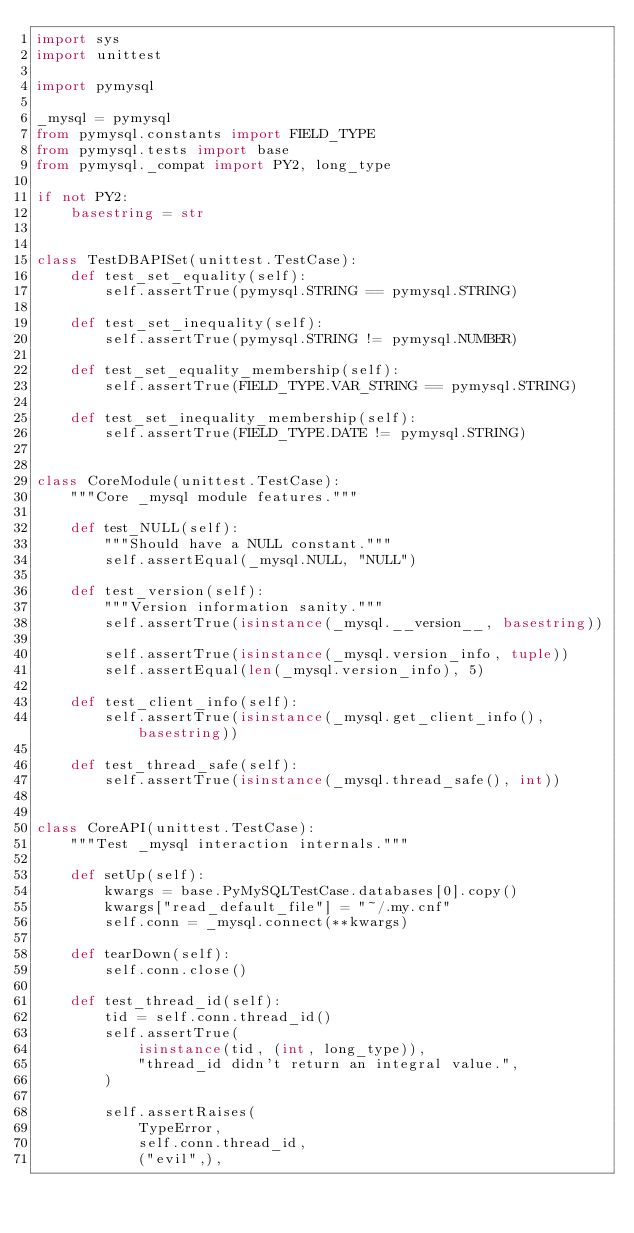<code> <loc_0><loc_0><loc_500><loc_500><_Python_>import sys
import unittest

import pymysql

_mysql = pymysql
from pymysql.constants import FIELD_TYPE
from pymysql.tests import base
from pymysql._compat import PY2, long_type

if not PY2:
    basestring = str


class TestDBAPISet(unittest.TestCase):
    def test_set_equality(self):
        self.assertTrue(pymysql.STRING == pymysql.STRING)

    def test_set_inequality(self):
        self.assertTrue(pymysql.STRING != pymysql.NUMBER)

    def test_set_equality_membership(self):
        self.assertTrue(FIELD_TYPE.VAR_STRING == pymysql.STRING)

    def test_set_inequality_membership(self):
        self.assertTrue(FIELD_TYPE.DATE != pymysql.STRING)


class CoreModule(unittest.TestCase):
    """Core _mysql module features."""

    def test_NULL(self):
        """Should have a NULL constant."""
        self.assertEqual(_mysql.NULL, "NULL")

    def test_version(self):
        """Version information sanity."""
        self.assertTrue(isinstance(_mysql.__version__, basestring))

        self.assertTrue(isinstance(_mysql.version_info, tuple))
        self.assertEqual(len(_mysql.version_info), 5)

    def test_client_info(self):
        self.assertTrue(isinstance(_mysql.get_client_info(), basestring))

    def test_thread_safe(self):
        self.assertTrue(isinstance(_mysql.thread_safe(), int))


class CoreAPI(unittest.TestCase):
    """Test _mysql interaction internals."""

    def setUp(self):
        kwargs = base.PyMySQLTestCase.databases[0].copy()
        kwargs["read_default_file"] = "~/.my.cnf"
        self.conn = _mysql.connect(**kwargs)

    def tearDown(self):
        self.conn.close()

    def test_thread_id(self):
        tid = self.conn.thread_id()
        self.assertTrue(
            isinstance(tid, (int, long_type)),
            "thread_id didn't return an integral value.",
        )

        self.assertRaises(
            TypeError,
            self.conn.thread_id,
            ("evil",),</code> 